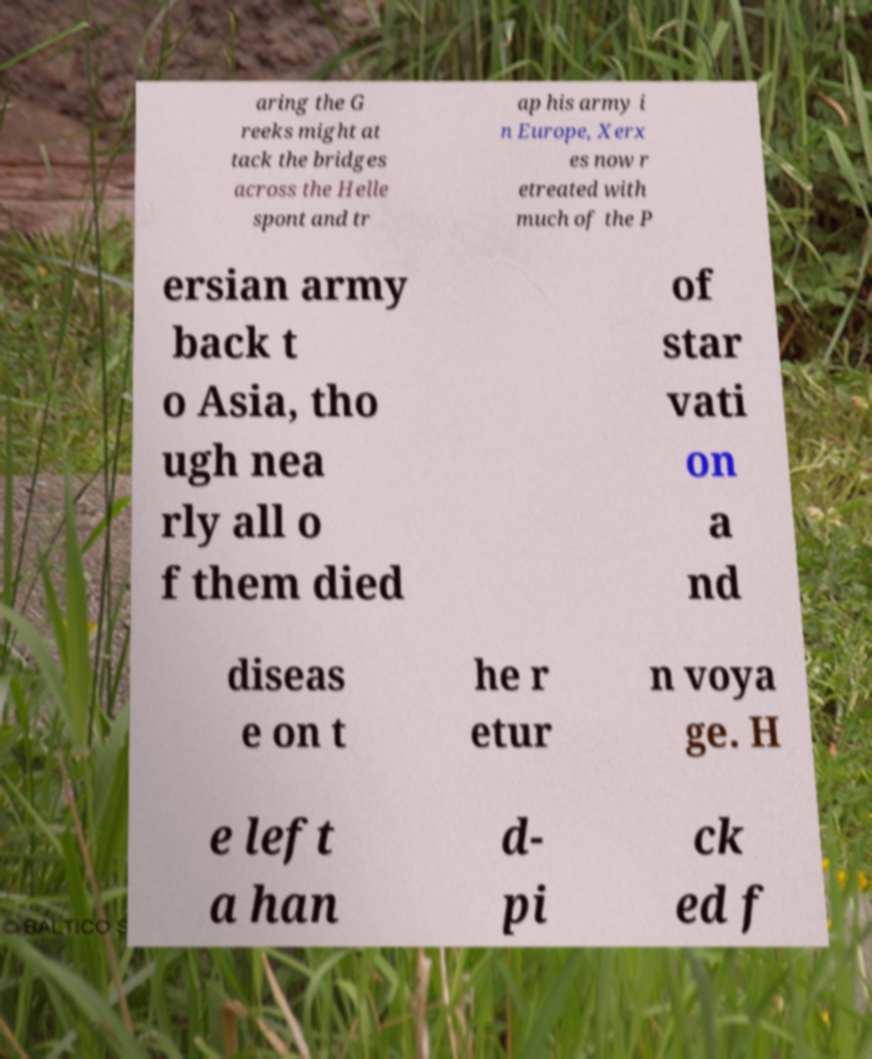For documentation purposes, I need the text within this image transcribed. Could you provide that? aring the G reeks might at tack the bridges across the Helle spont and tr ap his army i n Europe, Xerx es now r etreated with much of the P ersian army back t o Asia, tho ugh nea rly all o f them died of star vati on a nd diseas e on t he r etur n voya ge. H e left a han d- pi ck ed f 